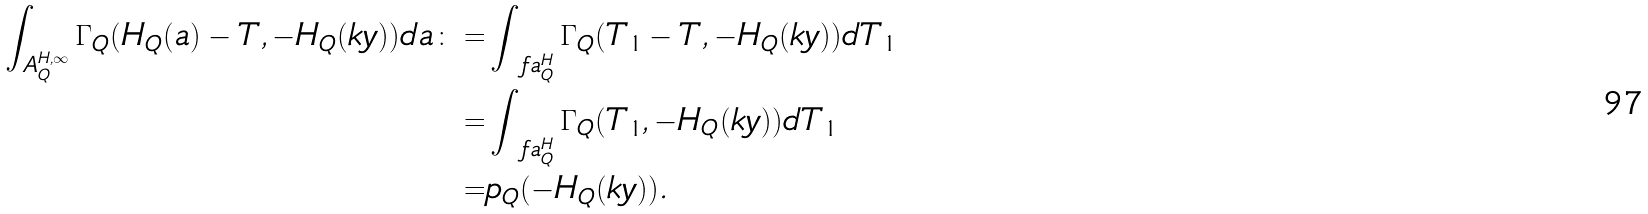<formula> <loc_0><loc_0><loc_500><loc_500>\int _ { A _ { Q } ^ { H , \infty } } \Gamma _ { Q } ( H _ { Q } ( a ) - T , - H _ { Q } ( k y ) ) d a \colon = & \int _ { \ f a _ { Q } ^ { H } } \Gamma _ { Q } ( T _ { 1 } - T , - H _ { Q } ( k y ) ) d T _ { 1 } \\ = & \int _ { \ f a _ { Q } ^ { H } } \Gamma _ { Q } ( T _ { 1 } , - H _ { Q } ( k y ) ) d T _ { 1 } \\ = & p _ { Q } ( - H _ { Q } ( k y ) ) .</formula> 